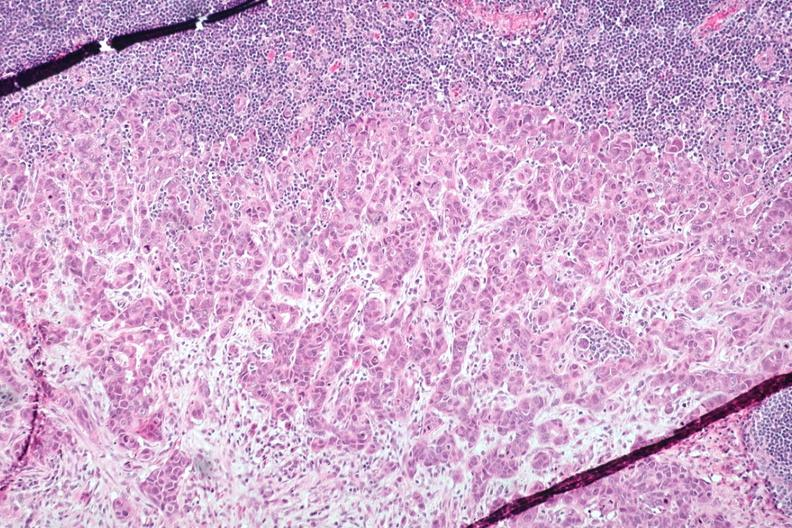what is present?
Answer the question using a single word or phrase. Metastatic adenocarcinoma 